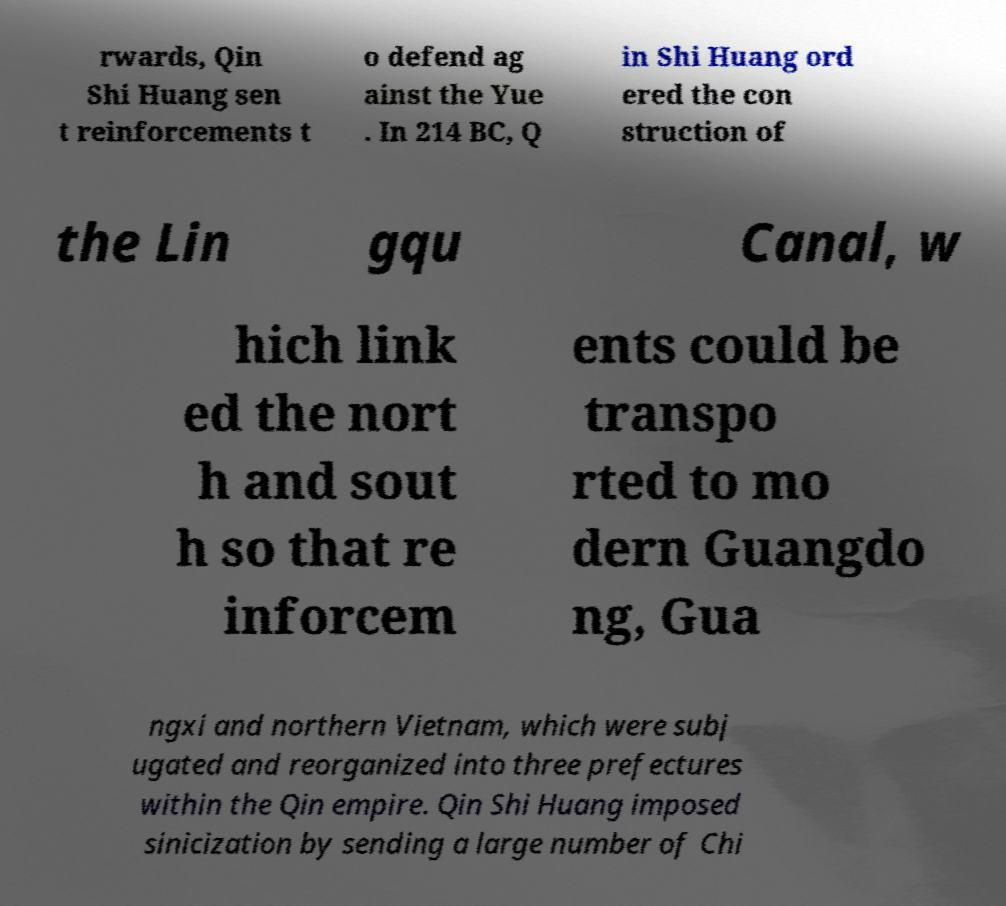Please read and relay the text visible in this image. What does it say? rwards, Qin Shi Huang sen t reinforcements t o defend ag ainst the Yue . In 214 BC, Q in Shi Huang ord ered the con struction of the Lin gqu Canal, w hich link ed the nort h and sout h so that re inforcem ents could be transpo rted to mo dern Guangdo ng, Gua ngxi and northern Vietnam, which were subj ugated and reorganized into three prefectures within the Qin empire. Qin Shi Huang imposed sinicization by sending a large number of Chi 